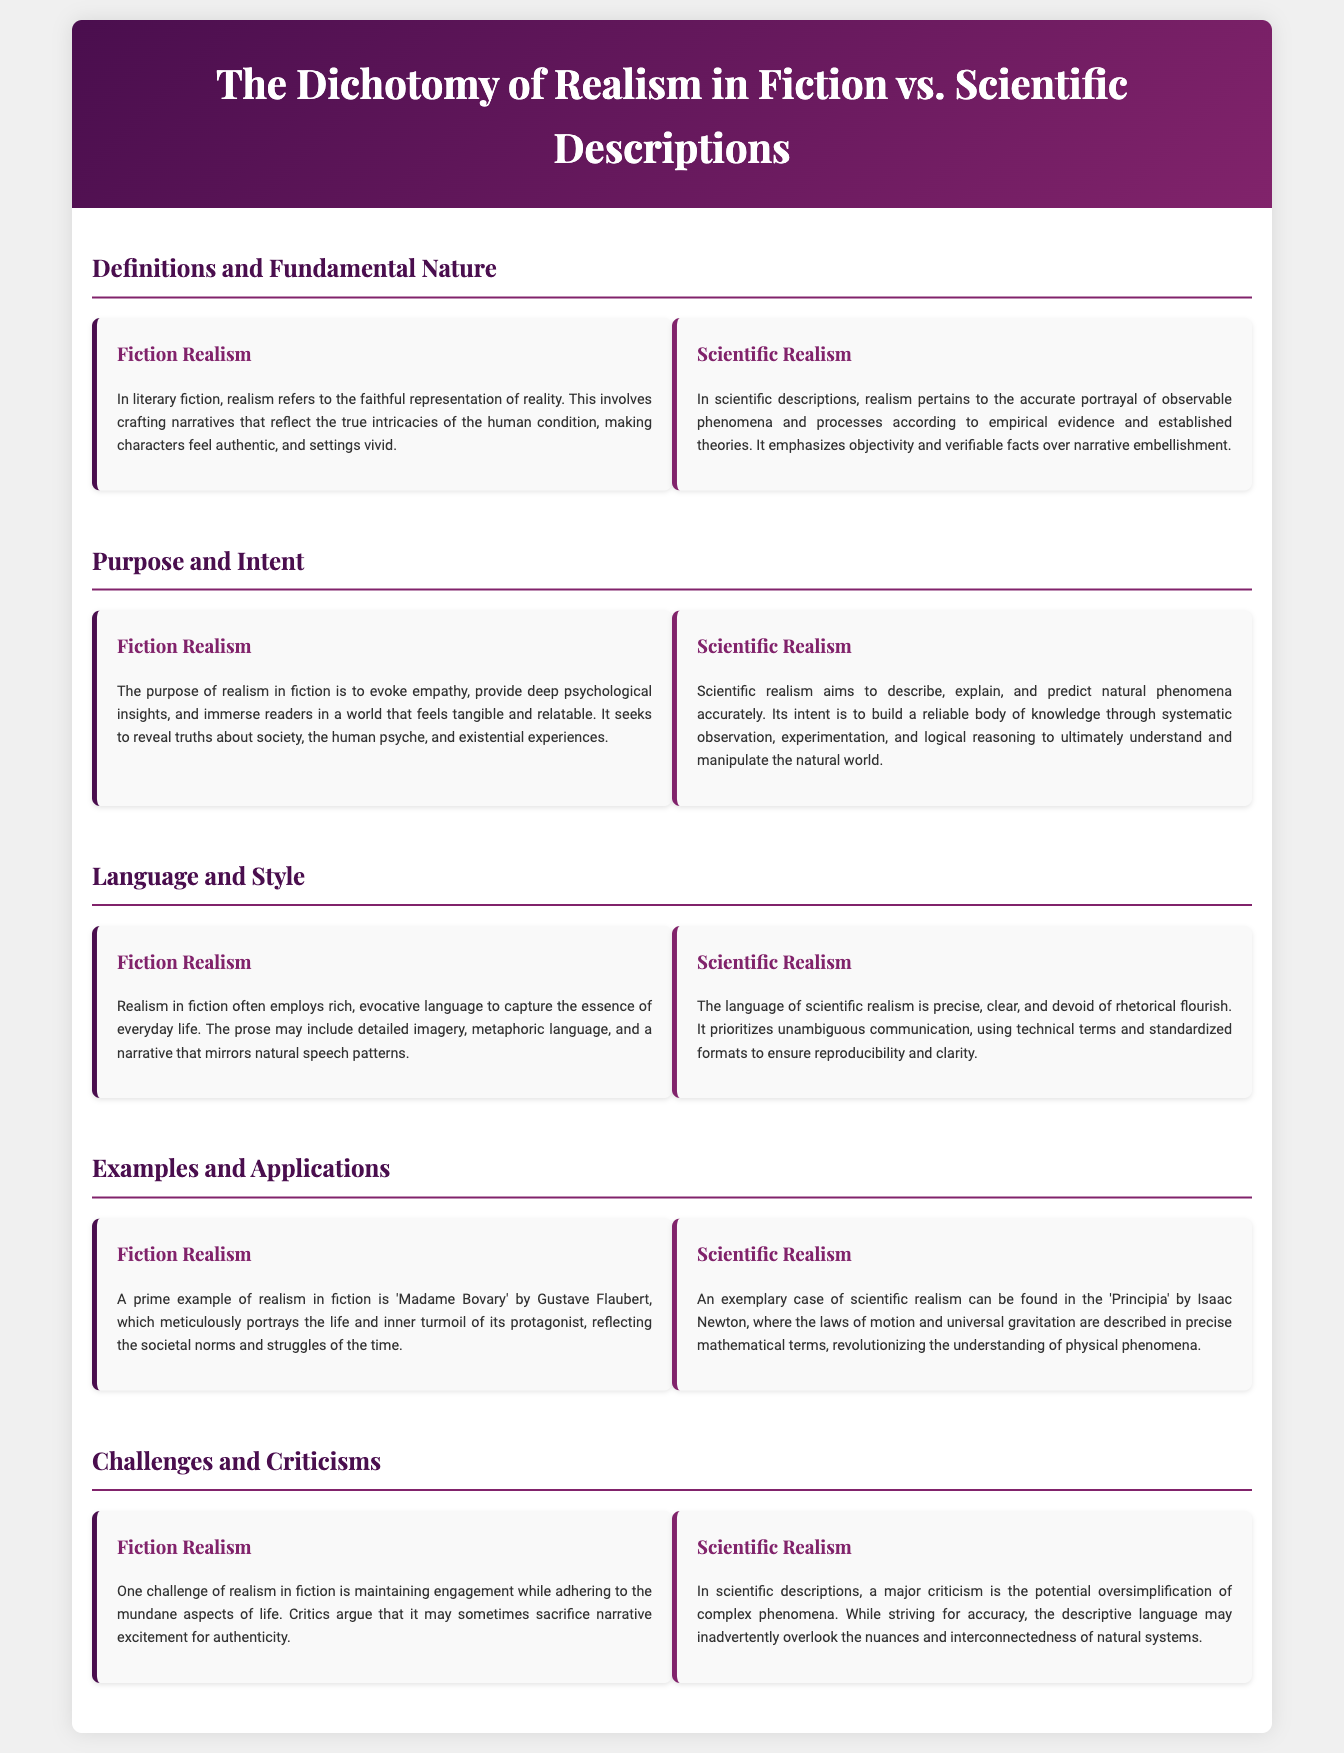What is the title of the infographic? The title can be found in the header section of the document, which states "The Dichotomy of Realism in Fiction vs. Scientific Descriptions."
Answer: The Dichotomy of Realism in Fiction vs. Scientific Descriptions What is one example of realism in fiction? An example can be found in the section titled "Examples and Applications," which mentions "Madame Bovary" by Gustave Flaubert.
Answer: Madame Bovary What does scientific realism prioritize? The document states under "Scientific Realism" that it prioritizes "objectivity and verifiable facts."
Answer: Objectivity and verifiable facts What is a challenge of realism in fiction? Under "Challenges and Criticisms," it is noted that a challenge is "maintaining engagement while adhering to the mundane aspects of life."
Answer: Maintaining engagement In which section are definitions provided? The section titled "Definitions and Fundamental Nature" contains the definitions for both types of realism.
Answer: Definitions and Fundamental Nature What does the language of scientific realism prioritize? In the "Language and Style" section, it mentions that scientific realism prioritizes "unambiguous communication."
Answer: Unambiguous communication What is the aim of scientific realism? The goal of scientific realism, as stated in the document, is "to describe, explain, and predict natural phenomena accurately."
Answer: To describe, explain, and predict natural phenomena accurately What is the intent of realism in fiction? In the "Purpose and Intent" section of the infographic, it states the intent is "to evoke empathy."
Answer: To evoke empathy What type of comparison is made in the document? The document compares "Fiction Realism" and "Scientific Realism."
Answer: Fiction Realism and Scientific Realism 